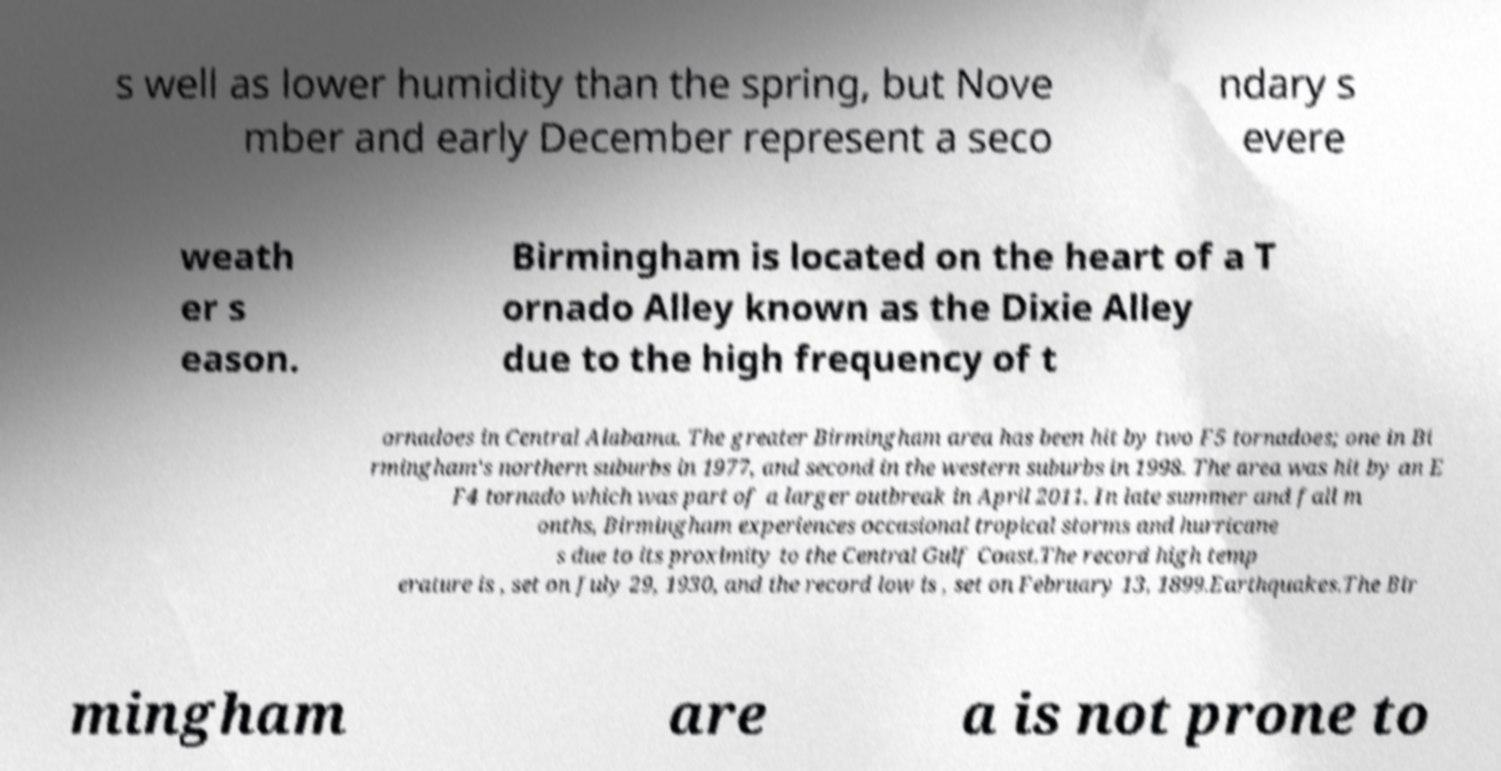Please identify and transcribe the text found in this image. s well as lower humidity than the spring, but Nove mber and early December represent a seco ndary s evere weath er s eason. Birmingham is located on the heart of a T ornado Alley known as the Dixie Alley due to the high frequency of t ornadoes in Central Alabama. The greater Birmingham area has been hit by two F5 tornadoes; one in Bi rmingham's northern suburbs in 1977, and second in the western suburbs in 1998. The area was hit by an E F4 tornado which was part of a larger outbreak in April 2011. In late summer and fall m onths, Birmingham experiences occasional tropical storms and hurricane s due to its proximity to the Central Gulf Coast.The record high temp erature is , set on July 29, 1930, and the record low is , set on February 13, 1899.Earthquakes.The Bir mingham are a is not prone to 